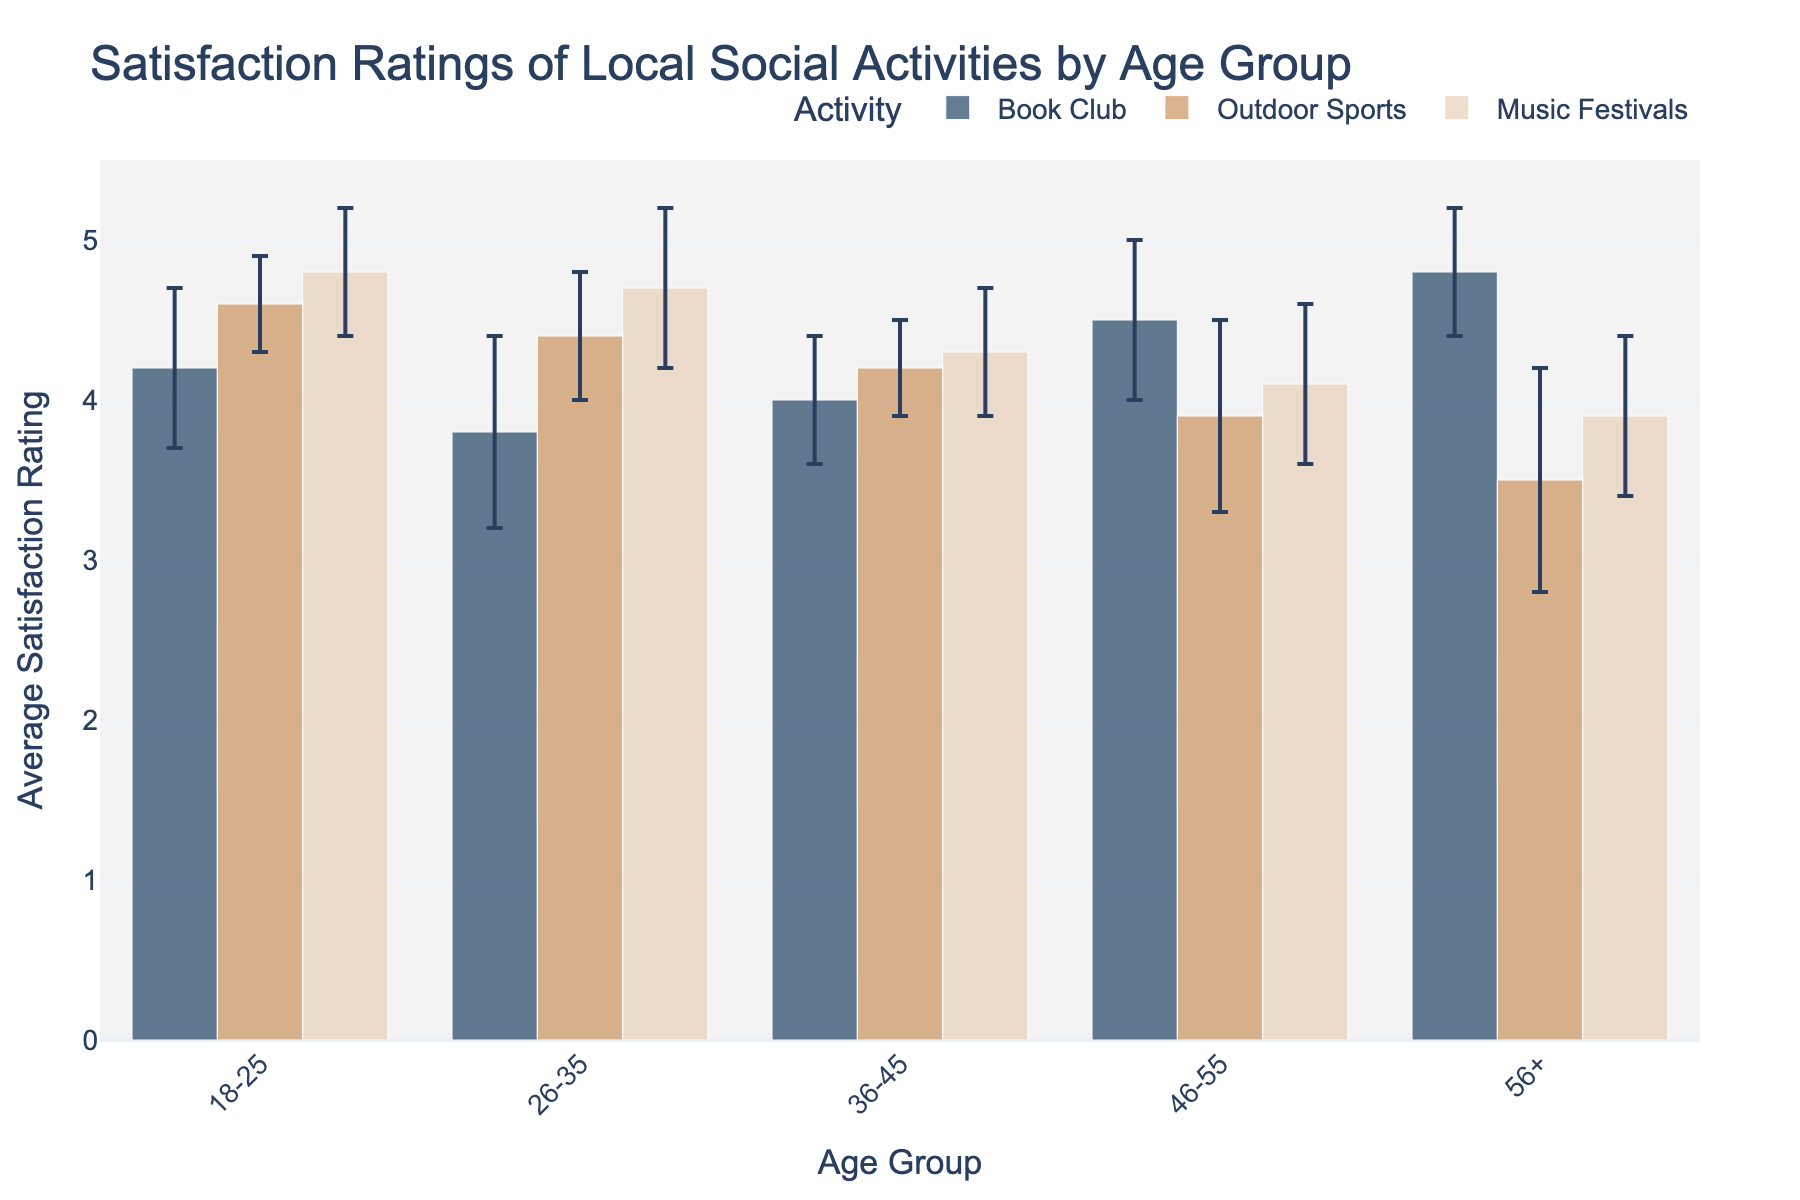What is the average satisfaction rating for the Music Festivals among the 18-25 age group? The bar for the Music Festivals in the 18-25 age group shows an average satisfaction rating of 4.8.
Answer: 4.8 Which activity in the 46-55 age group has the highest average satisfaction rating? Among the activities in the 46-55 age group, the Book Club has the highest average satisfaction rating, which is 4.5.
Answer: Book Club How does the average satisfaction rating of Outdoor Sports for the 56+ age group compare to that of the 18-25 age group? The average satisfaction rating of Outdoor Sports for the 56+ age group is 3.5, while it is 4.6 for the 18-25 age group. The rating for the 18-25 group is higher.
Answer: Higher in 18-25 age group What is the difference in the average satisfaction rating of Music Festivals between the 26-35 and 36-45 age groups? The average satisfaction rating for Music Festivals is 4.7 for the 26-35 age group and 4.3 for the 36-45 age group. The difference is 4.7 - 4.3 = 0.4.
Answer: 0.4 Which age group has the most variation (largest error margin) in their average satisfaction rating for Outdoor Sports? By looking at the error margins for Outdoor Sports, the 56+ age group has the largest error margin of 0.7.
Answer: 56+ What is the combined average satisfaction rating for Book Club across all age groups? The average satisfaction ratings for Book Club across each age group are: 18-25 (4.2), 26-35 (3.8), 36-45 (4.0), 46-55 (4.5), and 56+ (4.8). Summing these gives 4.2 + 3.8 + 4.0 + 4.5 + 4.8 = 21.3. The combined average is 21.3 / 5 = 4.26.
Answer: 4.26 What age group has the smallest error margin for Music Festivals? The error margins for Music Festivals are 0.4 (18-25), 0.5 (26-35), 0.4 (36-45), 0.5 (46-55), and 0.5 (56+). The smallest error margin is 0.4, found in the 18-25 and 36-45 age groups.
Answer: 18-25 and 36-45 What is the rank order of age groups based on their average satisfaction rating for Outdoor Sports from highest to lowest? The average satisfaction ratings for Outdoor Sports by age group are: 18-25 (4.6), 26-35 (4.4), 36-45 (4.2), 46-55 (3.9), and 56+ (3.5). Hence, the rank order from highest to lowest is: 18-25, 26-35, 36-45, 46-55, 56+.
Answer: 18-25, 26-35, 36-45, 46-55, 56+ Which activity has the highest average satisfaction rating across all age groups? The highest satisfaction rating across all activities and age groups is for Music Festivals in the 18-25 age group, which is 4.8.
Answer: Music Festivals 